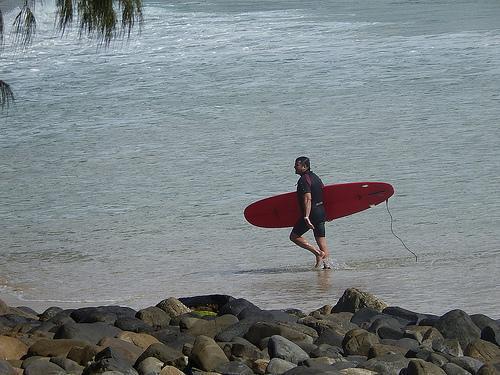How many people are in the photo?
Give a very brief answer. 1. 